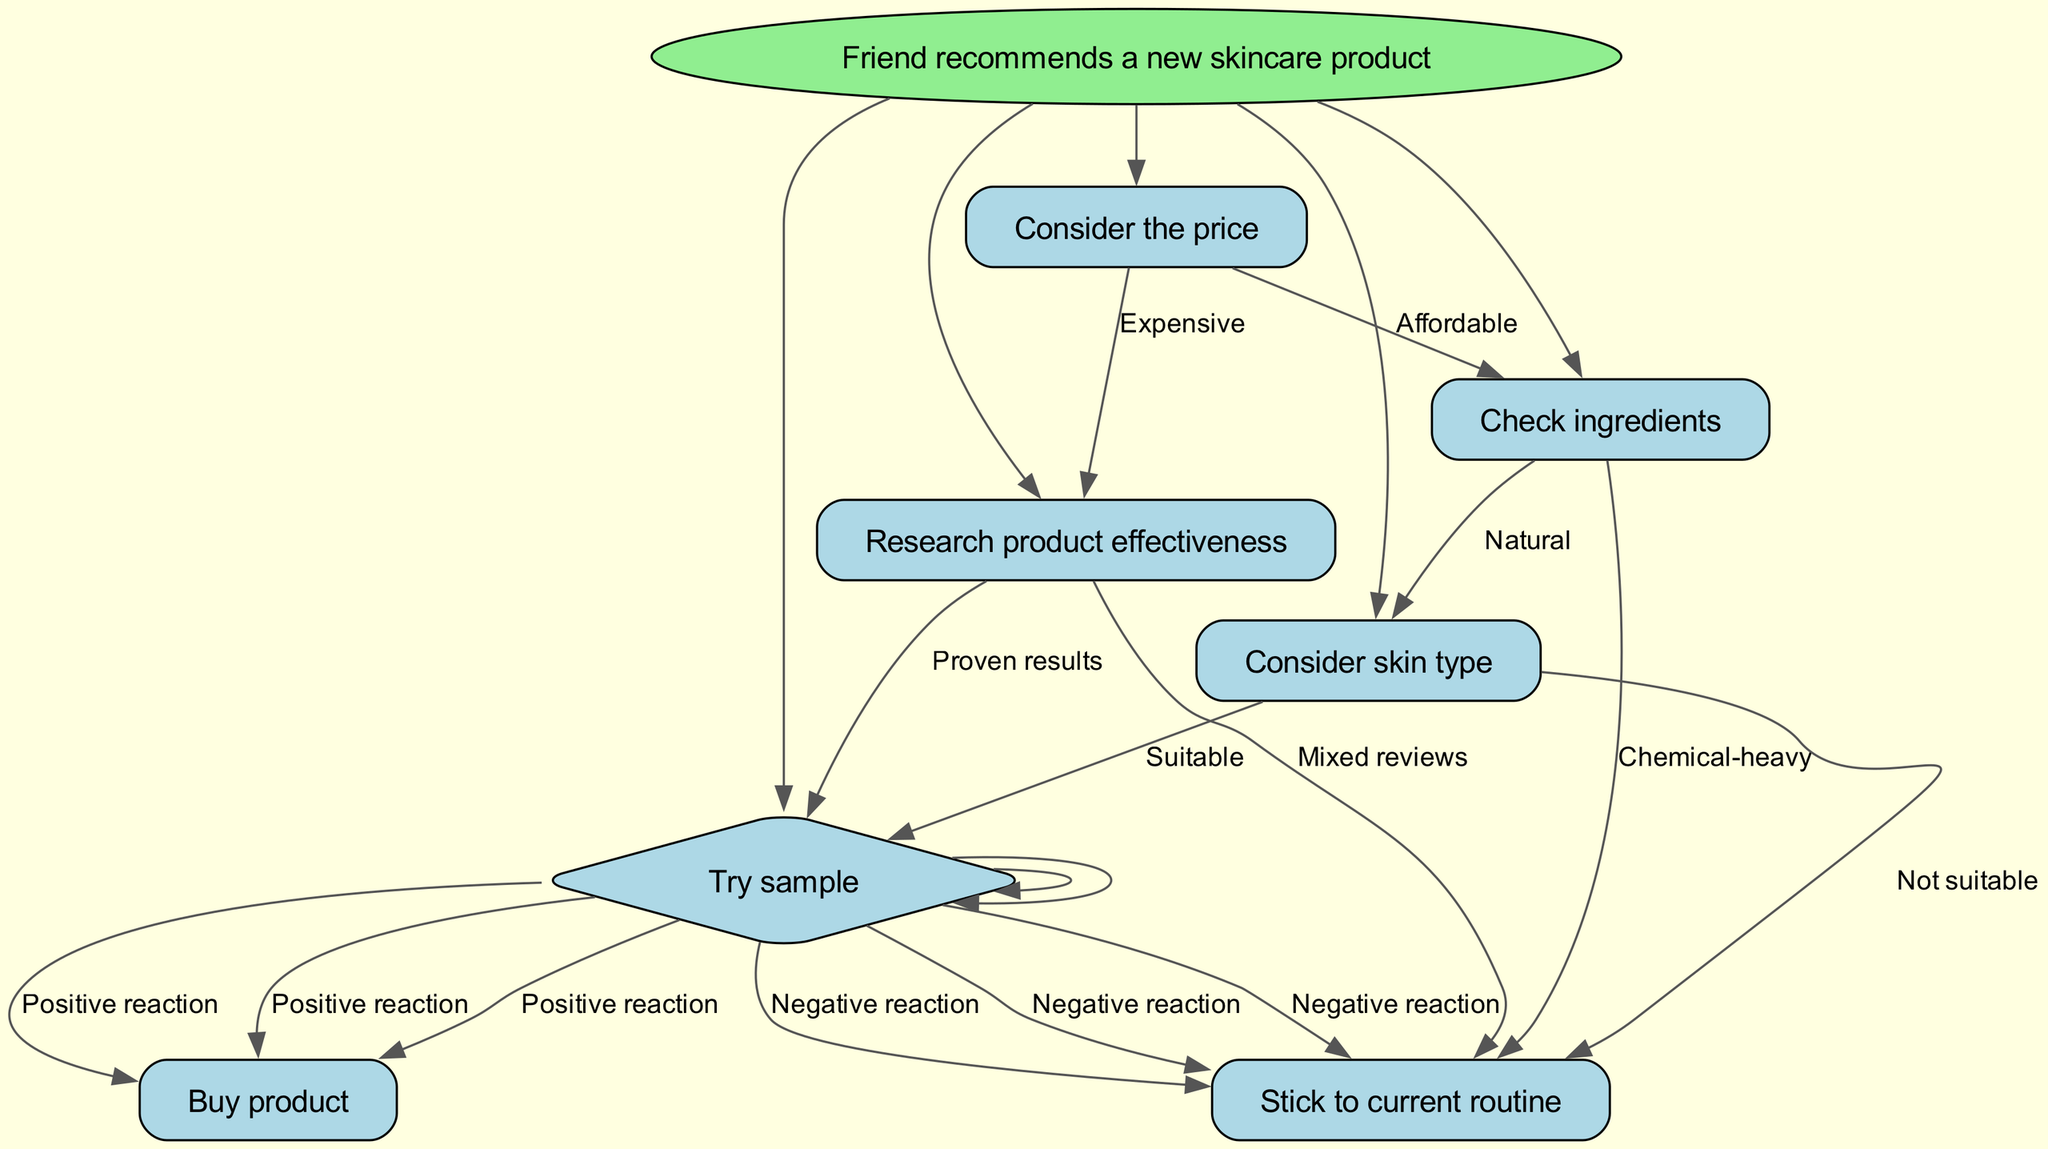What is the root node of the decision tree? The root node is labeled "Friend recommends a new skincare product," which initiates the decision-making process in the diagram.
Answer: Friend recommends a new skincare product How many main decisions are there in the tree? There are five main decisions connected to the root node, representing the different choices one makes after receiving a product recommendation.
Answer: 5 What do you do if the product is expensive? If the product is expensive, the next step is to "Research product effectiveness," indicating that more information is needed before making a decision.
Answer: Research product effectiveness What happens if there are mixed reviews after researching the product's effectiveness? If there are mixed reviews, you decide to "Stick to current routine," indicating a preference not to try the new product based on uncertainty about its effectiveness.
Answer: Stick to current routine If the ingredients are chemical-heavy, what is the next step? If the ingredients of the product are chemical-heavy, the action to take is to "Stick to current routine," which shows a decision not to proceed with trying the product.
Answer: Stick to current routine What should you consider after checking if the ingredients are natural? After checking if the ingredients are natural, you should "Consider skin type" to determine if the product will be suitable for your skin.
Answer: Consider skin type What do you do if you have a positive reaction after trying the sample? If you have a positive reaction after trying the sample, the action to take is to "Buy product"; this indicates a successful trial of the new skincare product.
Answer: Buy product What is the decision if the skin type is not suitable for the product? If the skin type is not suitable, the decision is to "Stick to current routine," which implies continuing with existing skincare products rather than trying the new one.
Answer: Stick to current routine What indicates you should try a sample? A suitable skin type or proven results from the research indicates that you should try a sample of the new skincare product.
Answer: Try sample 